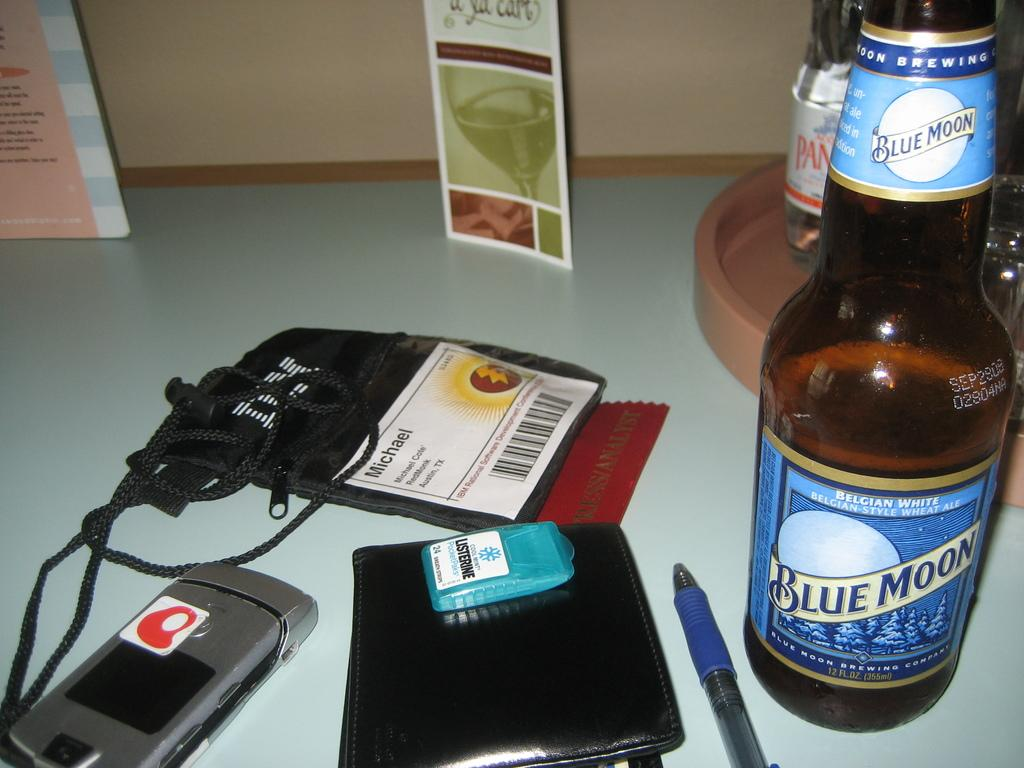Provide a one-sentence caption for the provided image. A bottle of Blue Moon beer sits on a desk along with many personal items. 